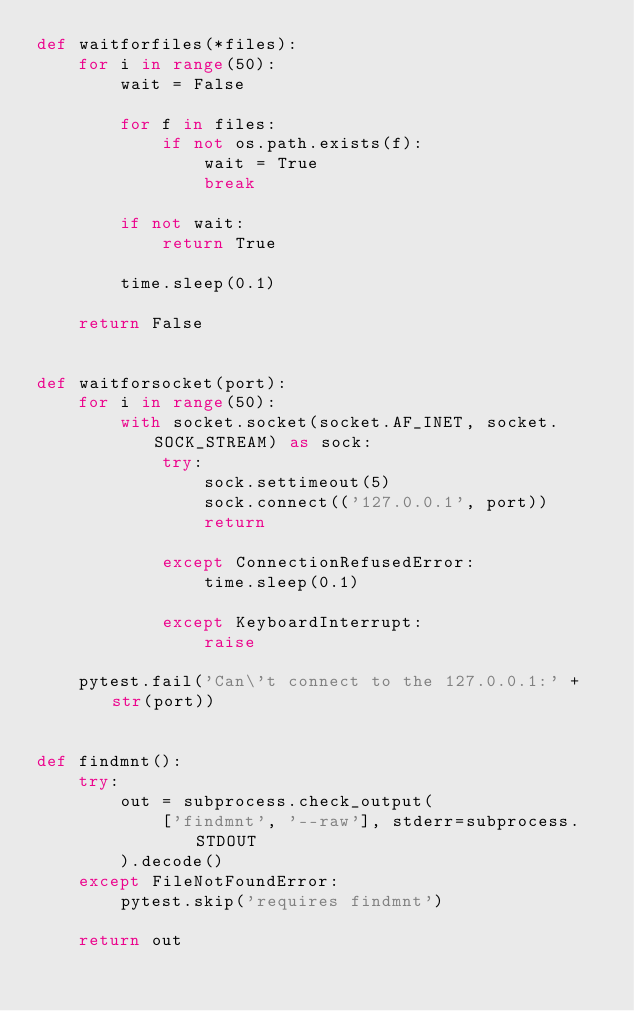<code> <loc_0><loc_0><loc_500><loc_500><_Python_>def waitforfiles(*files):
    for i in range(50):
        wait = False

        for f in files:
            if not os.path.exists(f):
                wait = True
                break

        if not wait:
            return True

        time.sleep(0.1)

    return False


def waitforsocket(port):
    for i in range(50):
        with socket.socket(socket.AF_INET, socket.SOCK_STREAM) as sock:
            try:
                sock.settimeout(5)
                sock.connect(('127.0.0.1', port))
                return

            except ConnectionRefusedError:
                time.sleep(0.1)

            except KeyboardInterrupt:
                raise

    pytest.fail('Can\'t connect to the 127.0.0.1:' + str(port))


def findmnt():
    try:
        out = subprocess.check_output(
            ['findmnt', '--raw'], stderr=subprocess.STDOUT
        ).decode()
    except FileNotFoundError:
        pytest.skip('requires findmnt')

    return out

</code> 